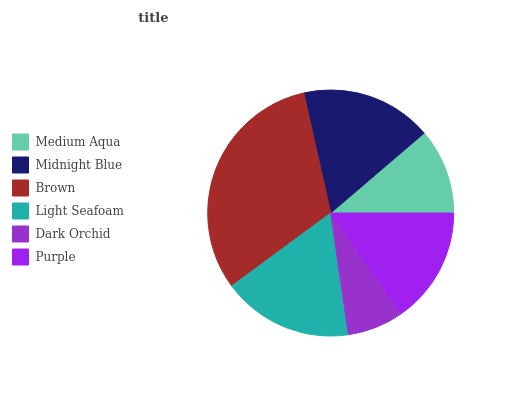Is Dark Orchid the minimum?
Answer yes or no. Yes. Is Brown the maximum?
Answer yes or no. Yes. Is Midnight Blue the minimum?
Answer yes or no. No. Is Midnight Blue the maximum?
Answer yes or no. No. Is Midnight Blue greater than Medium Aqua?
Answer yes or no. Yes. Is Medium Aqua less than Midnight Blue?
Answer yes or no. Yes. Is Medium Aqua greater than Midnight Blue?
Answer yes or no. No. Is Midnight Blue less than Medium Aqua?
Answer yes or no. No. Is Light Seafoam the high median?
Answer yes or no. Yes. Is Purple the low median?
Answer yes or no. Yes. Is Medium Aqua the high median?
Answer yes or no. No. Is Dark Orchid the low median?
Answer yes or no. No. 